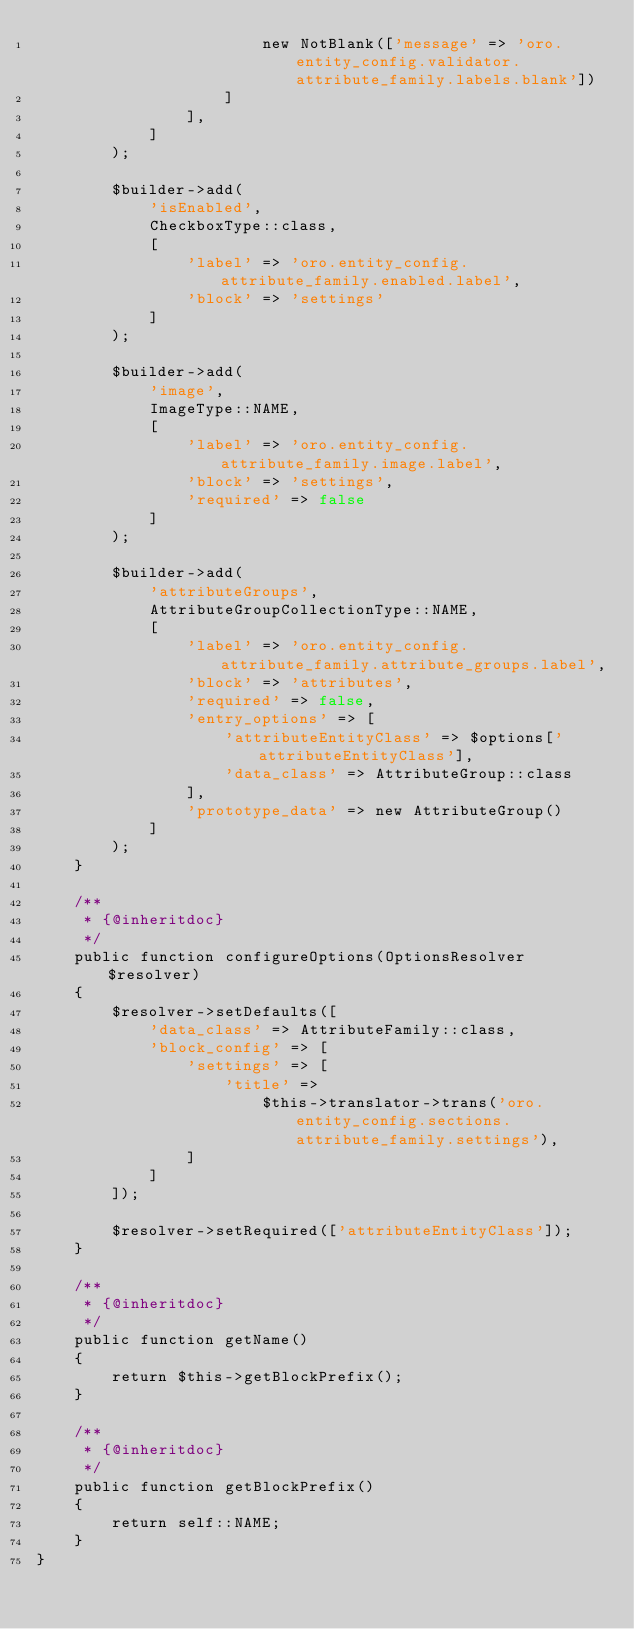<code> <loc_0><loc_0><loc_500><loc_500><_PHP_>                        new NotBlank(['message' => 'oro.entity_config.validator.attribute_family.labels.blank'])
                    ]
                ],
            ]
        );

        $builder->add(
            'isEnabled',
            CheckboxType::class,
            [
                'label' => 'oro.entity_config.attribute_family.enabled.label',
                'block' => 'settings'
            ]
        );

        $builder->add(
            'image',
            ImageType::NAME,
            [
                'label' => 'oro.entity_config.attribute_family.image.label',
                'block' => 'settings',
                'required' => false
            ]
        );

        $builder->add(
            'attributeGroups',
            AttributeGroupCollectionType::NAME,
            [
                'label' => 'oro.entity_config.attribute_family.attribute_groups.label',
                'block' => 'attributes',
                'required' => false,
                'entry_options' => [
                    'attributeEntityClass' => $options['attributeEntityClass'],
                    'data_class' => AttributeGroup::class
                ],
                'prototype_data' => new AttributeGroup()
            ]
        );
    }

    /**
     * {@inheritdoc}
     */
    public function configureOptions(OptionsResolver $resolver)
    {
        $resolver->setDefaults([
            'data_class' => AttributeFamily::class,
            'block_config' => [
                'settings' => [
                    'title' =>
                        $this->translator->trans('oro.entity_config.sections.attribute_family.settings'),
                ]
            ]
        ]);

        $resolver->setRequired(['attributeEntityClass']);
    }

    /**
     * {@inheritdoc}
     */
    public function getName()
    {
        return $this->getBlockPrefix();
    }

    /**
     * {@inheritdoc}
     */
    public function getBlockPrefix()
    {
        return self::NAME;
    }
}
</code> 